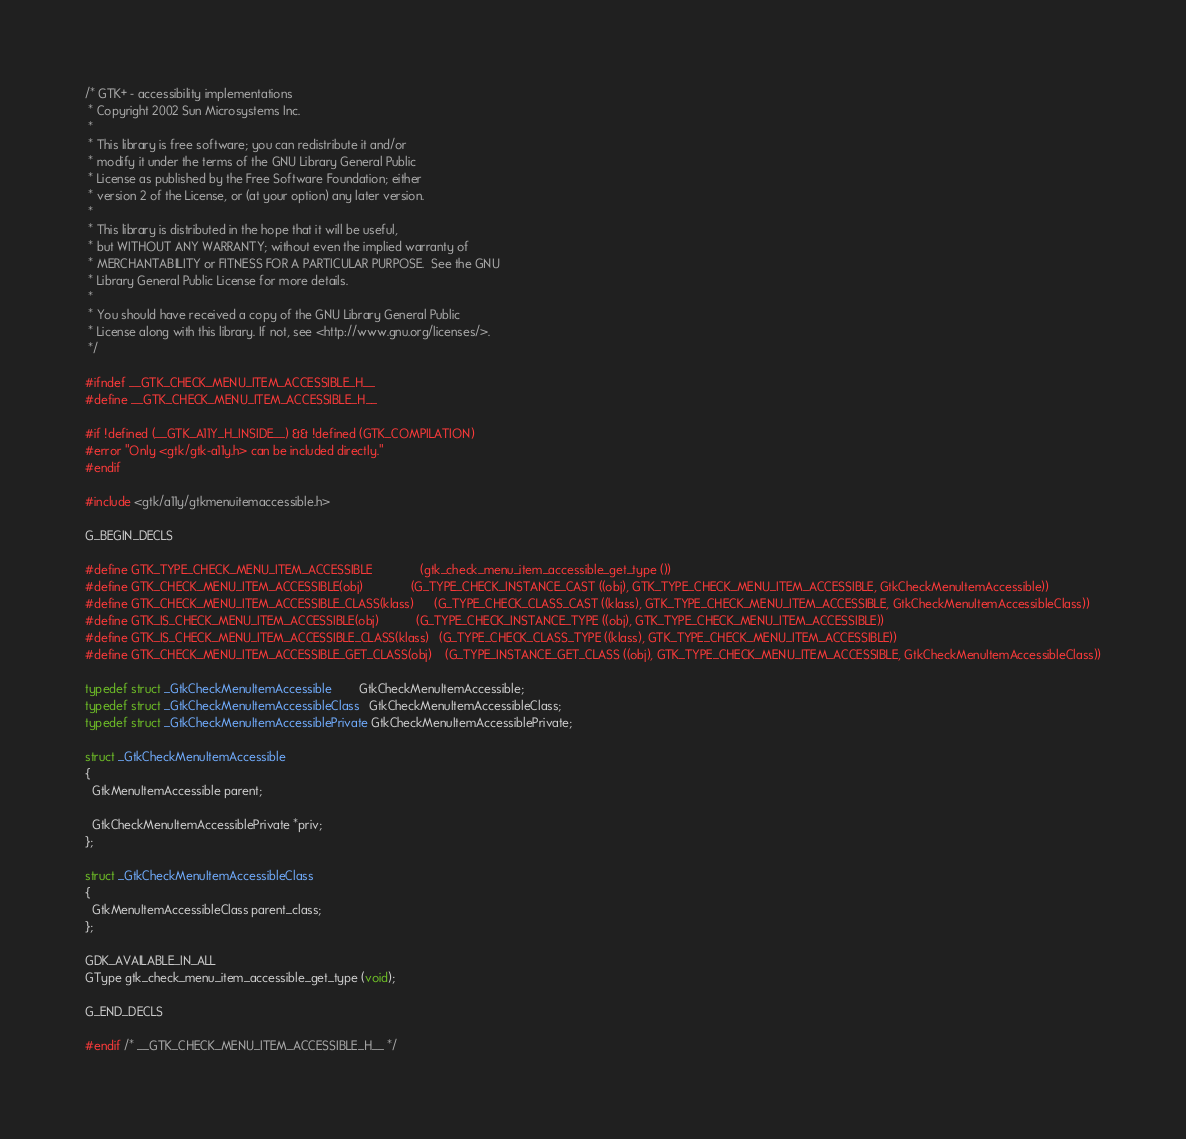<code> <loc_0><loc_0><loc_500><loc_500><_C_>/* GTK+ - accessibility implementations
 * Copyright 2002 Sun Microsystems Inc.
 *
 * This library is free software; you can redistribute it and/or
 * modify it under the terms of the GNU Library General Public
 * License as published by the Free Software Foundation; either
 * version 2 of the License, or (at your option) any later version.
 *
 * This library is distributed in the hope that it will be useful,
 * but WITHOUT ANY WARRANTY; without even the implied warranty of
 * MERCHANTABILITY or FITNESS FOR A PARTICULAR PURPOSE.  See the GNU
 * Library General Public License for more details.
 *
 * You should have received a copy of the GNU Library General Public
 * License along with this library. If not, see <http://www.gnu.org/licenses/>.
 */

#ifndef __GTK_CHECK_MENU_ITEM_ACCESSIBLE_H__
#define __GTK_CHECK_MENU_ITEM_ACCESSIBLE_H__

#if !defined (__GTK_A11Y_H_INSIDE__) && !defined (GTK_COMPILATION)
#error "Only <gtk/gtk-a11y.h> can be included directly."
#endif

#include <gtk/a11y/gtkmenuitemaccessible.h>

G_BEGIN_DECLS

#define GTK_TYPE_CHECK_MENU_ITEM_ACCESSIBLE              (gtk_check_menu_item_accessible_get_type ())
#define GTK_CHECK_MENU_ITEM_ACCESSIBLE(obj)              (G_TYPE_CHECK_INSTANCE_CAST ((obj), GTK_TYPE_CHECK_MENU_ITEM_ACCESSIBLE, GtkCheckMenuItemAccessible))
#define GTK_CHECK_MENU_ITEM_ACCESSIBLE_CLASS(klass)      (G_TYPE_CHECK_CLASS_CAST ((klass), GTK_TYPE_CHECK_MENU_ITEM_ACCESSIBLE, GtkCheckMenuItemAccessibleClass))
#define GTK_IS_CHECK_MENU_ITEM_ACCESSIBLE(obj)           (G_TYPE_CHECK_INSTANCE_TYPE ((obj), GTK_TYPE_CHECK_MENU_ITEM_ACCESSIBLE))
#define GTK_IS_CHECK_MENU_ITEM_ACCESSIBLE_CLASS(klass)   (G_TYPE_CHECK_CLASS_TYPE ((klass), GTK_TYPE_CHECK_MENU_ITEM_ACCESSIBLE))
#define GTK_CHECK_MENU_ITEM_ACCESSIBLE_GET_CLASS(obj)    (G_TYPE_INSTANCE_GET_CLASS ((obj), GTK_TYPE_CHECK_MENU_ITEM_ACCESSIBLE, GtkCheckMenuItemAccessibleClass))

typedef struct _GtkCheckMenuItemAccessible        GtkCheckMenuItemAccessible;
typedef struct _GtkCheckMenuItemAccessibleClass   GtkCheckMenuItemAccessibleClass;
typedef struct _GtkCheckMenuItemAccessiblePrivate GtkCheckMenuItemAccessiblePrivate;

struct _GtkCheckMenuItemAccessible
{
  GtkMenuItemAccessible parent;

  GtkCheckMenuItemAccessiblePrivate *priv;
};

struct _GtkCheckMenuItemAccessibleClass
{
  GtkMenuItemAccessibleClass parent_class;
};

GDK_AVAILABLE_IN_ALL
GType gtk_check_menu_item_accessible_get_type (void);

G_END_DECLS

#endif /* __GTK_CHECK_MENU_ITEM_ACCESSIBLE_H__ */
</code> 